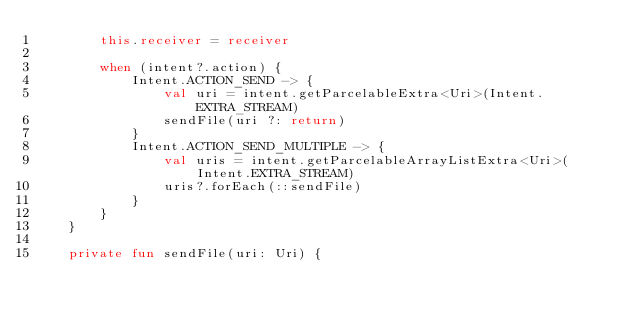Convert code to text. <code><loc_0><loc_0><loc_500><loc_500><_Kotlin_>        this.receiver = receiver

        when (intent?.action) {
            Intent.ACTION_SEND -> {
                val uri = intent.getParcelableExtra<Uri>(Intent.EXTRA_STREAM)
                sendFile(uri ?: return)
            }
            Intent.ACTION_SEND_MULTIPLE -> {
                val uris = intent.getParcelableArrayListExtra<Uri>(Intent.EXTRA_STREAM)
                uris?.forEach(::sendFile)
            }
        }
    }

    private fun sendFile(uri: Uri) {</code> 